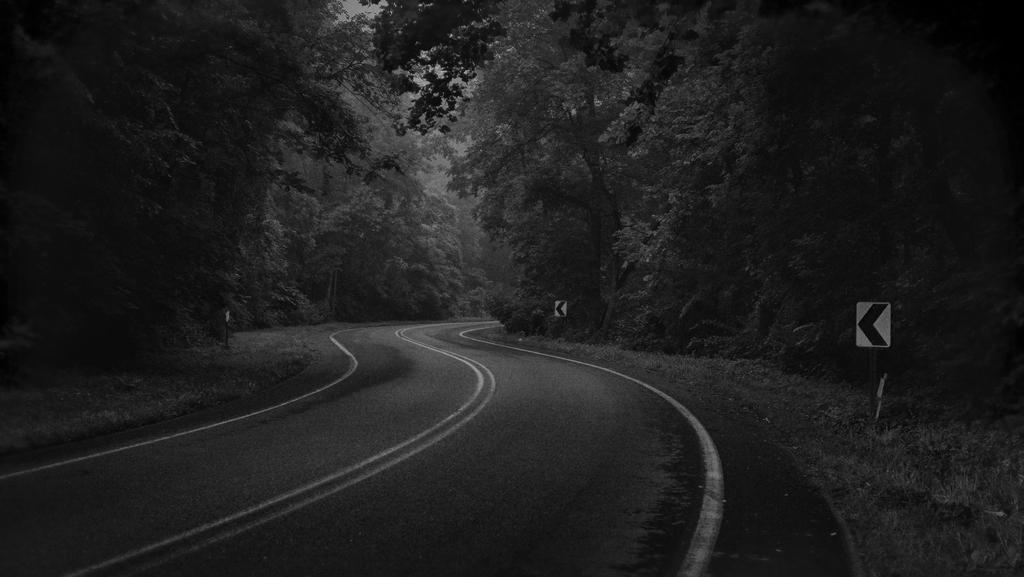What is the color scheme of the image? The image is black and white. What type of natural elements can be seen in the image? There are trees in the image. What man-made structures are present in the image? There are sign boards in the image. What type of pathway is visible in the image? There is a road in the image. What type of juice is being served at the expert's table in the image? There is no expert or table present in the image, nor is there any juice being served. 